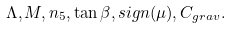Convert formula to latex. <formula><loc_0><loc_0><loc_500><loc_500>\Lambda , M , n _ { 5 } , \tan \beta , s i g n ( \mu ) , C _ { g r a v } .</formula> 